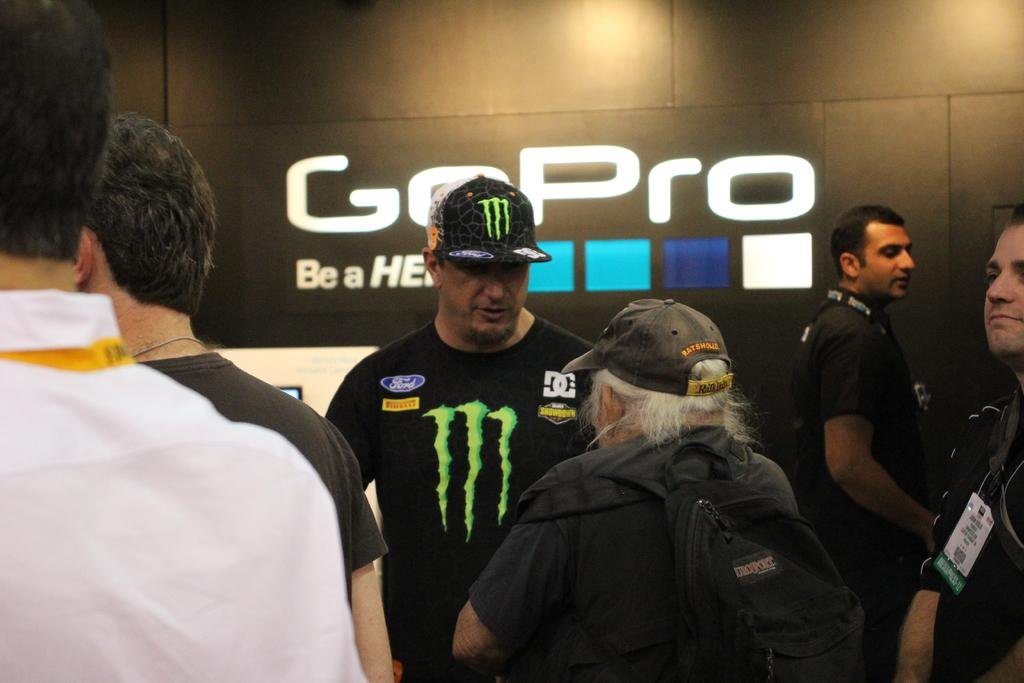Provide a one-sentence caption for the provided image. A man in a Monster t-shirt standing in front of a wall with the word GoPro on it. 